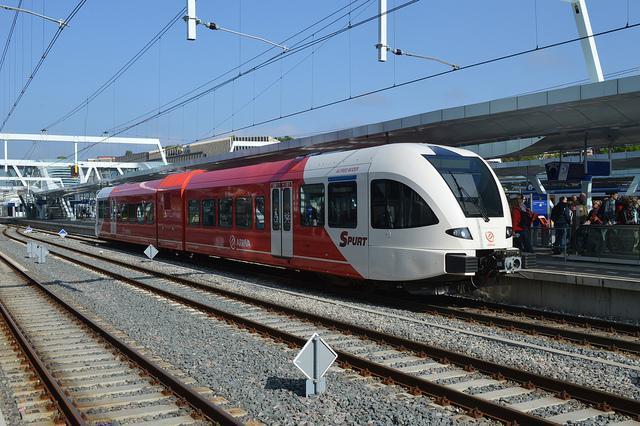What type power does this train use?
Indicate the correct choice and explain in the format: 'Answer: answer
Rationale: rationale.'
Options: Gas, diesel, coal, electrical. Answer: electrical.
Rationale: There are power lines above the trains. 